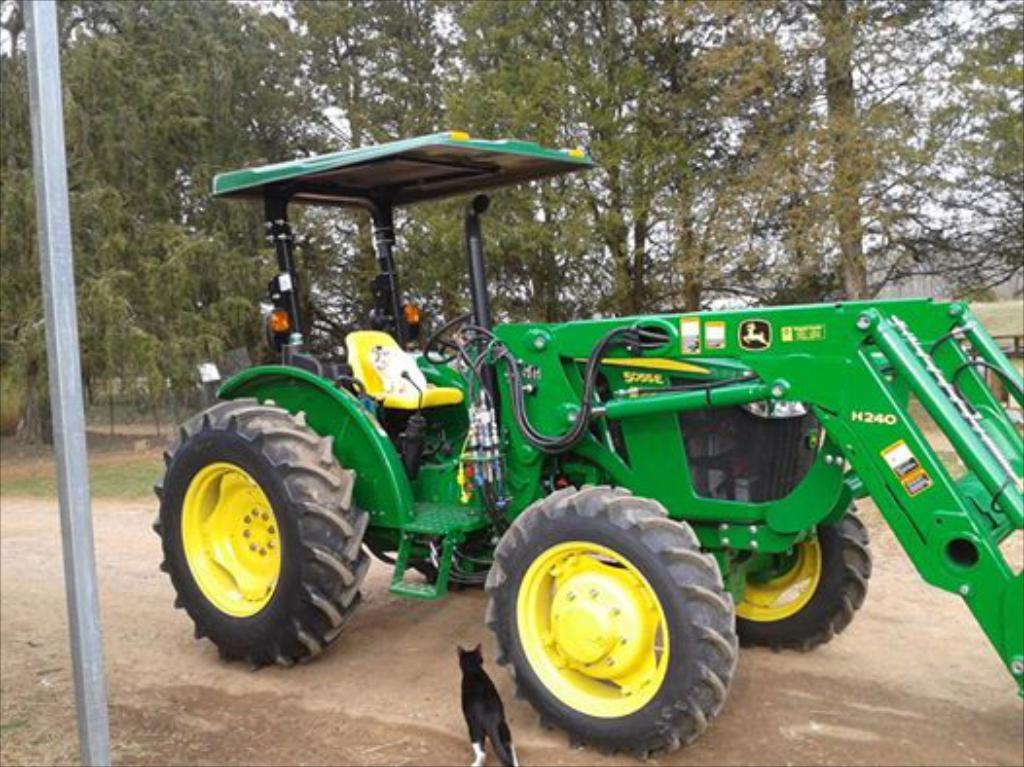What is the main subject of the image? There is a tractor in the image. What color is the tractor? The tractor is green. What is at the bottom of the image? There is a road at the bottom of the image. What type of animal can be seen in the image? There is a cat in the image. What color is the cat? The cat is black. What can be seen in the background of the image? There are many trees in the background of the image. Where is the pole located in the image? There is a pole on the left side of the image. What type of pipe is being used to expand the tractor in the image? There is no pipe or expansion activity present in the image. The tractor is a complete and stationary object. 